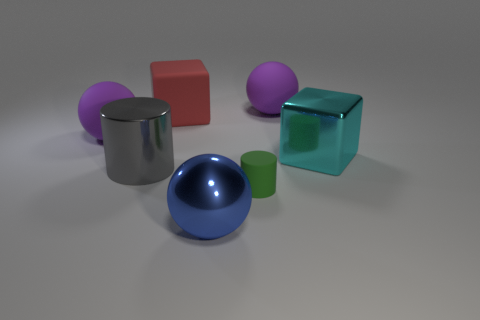How many objects are either rubber spheres to the left of the large red matte object or big blocks?
Ensure brevity in your answer.  3. What is the size of the ball that is in front of the thing that is right of the large purple thing on the right side of the big shiny cylinder?
Give a very brief answer. Large. There is a rubber object in front of the large rubber sphere on the left side of the big gray thing; what is its size?
Keep it short and to the point. Small. How many large objects are either cyan shiny blocks or green cylinders?
Offer a terse response. 1. Are there fewer yellow cylinders than blue metallic objects?
Make the answer very short. Yes. Are there any other things that are the same size as the green matte cylinder?
Offer a very short reply. No. Is the number of big red rubber blocks greater than the number of purple metallic cylinders?
Your answer should be compact. Yes. What number of other objects are there of the same color as the rubber cylinder?
Ensure brevity in your answer.  0. How many red rubber cubes are behind the block that is left of the large blue ball?
Your response must be concise. 0. Are there any large purple matte things behind the matte cylinder?
Your answer should be very brief. Yes. 